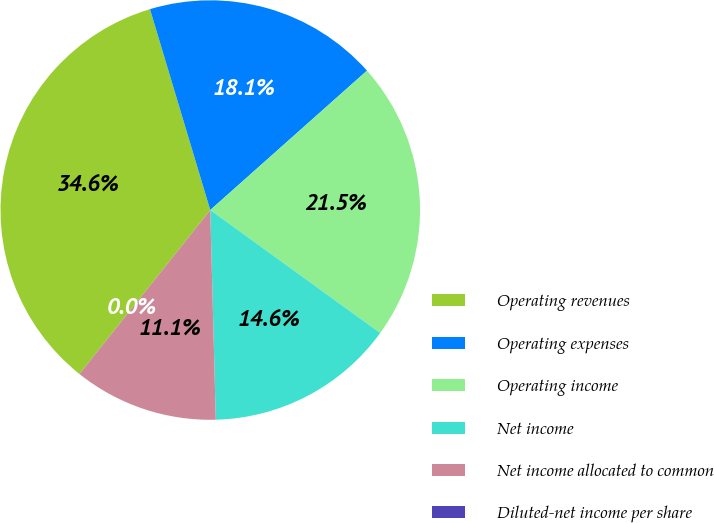Convert chart. <chart><loc_0><loc_0><loc_500><loc_500><pie_chart><fcel>Operating revenues<fcel>Operating expenses<fcel>Operating income<fcel>Net income<fcel>Net income allocated to common<fcel>Diluted-net income per share<nl><fcel>34.64%<fcel>18.07%<fcel>21.54%<fcel>14.61%<fcel>11.14%<fcel>0.0%<nl></chart> 